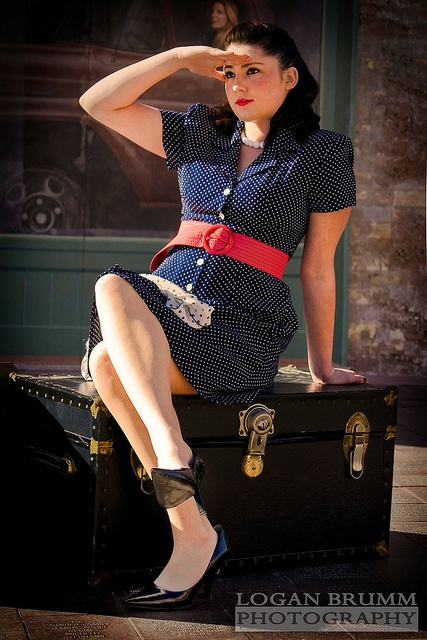Describe the objects in this image and their specific colors. I can see people in black, salmon, gray, and brown tones, suitcase in black, maroon, and gray tones, and car in black, maroon, and gray tones in this image. 